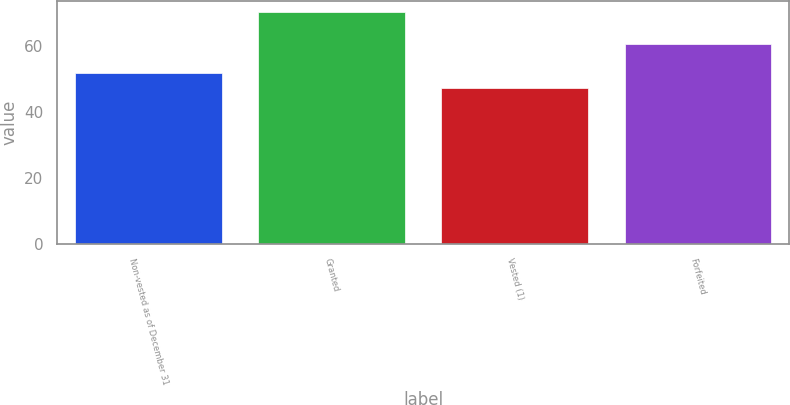Convert chart to OTSL. <chart><loc_0><loc_0><loc_500><loc_500><bar_chart><fcel>Non-vested as of December 31<fcel>Granted<fcel>Vested (1)<fcel>Forfeited<nl><fcel>52.03<fcel>70.42<fcel>47.43<fcel>60.77<nl></chart> 